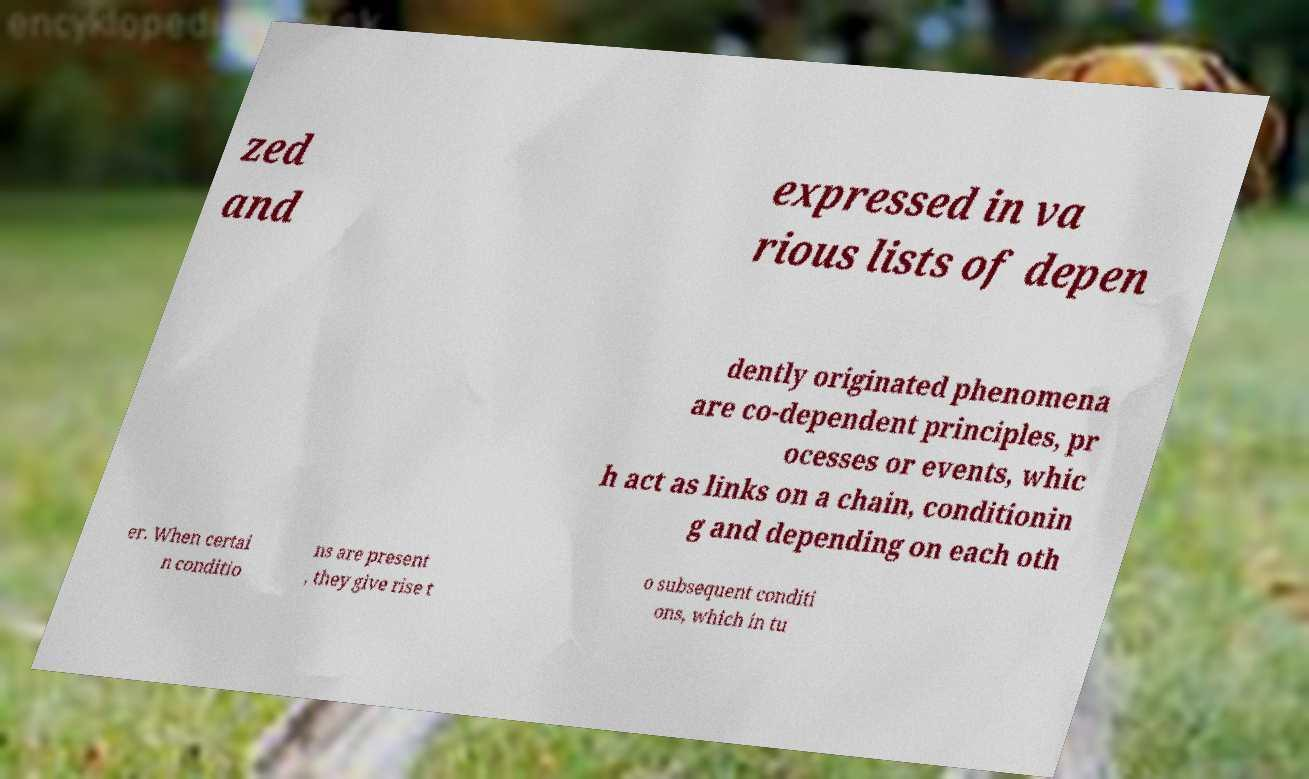For documentation purposes, I need the text within this image transcribed. Could you provide that? zed and expressed in va rious lists of depen dently originated phenomena are co-dependent principles, pr ocesses or events, whic h act as links on a chain, conditionin g and depending on each oth er. When certai n conditio ns are present , they give rise t o subsequent conditi ons, which in tu 